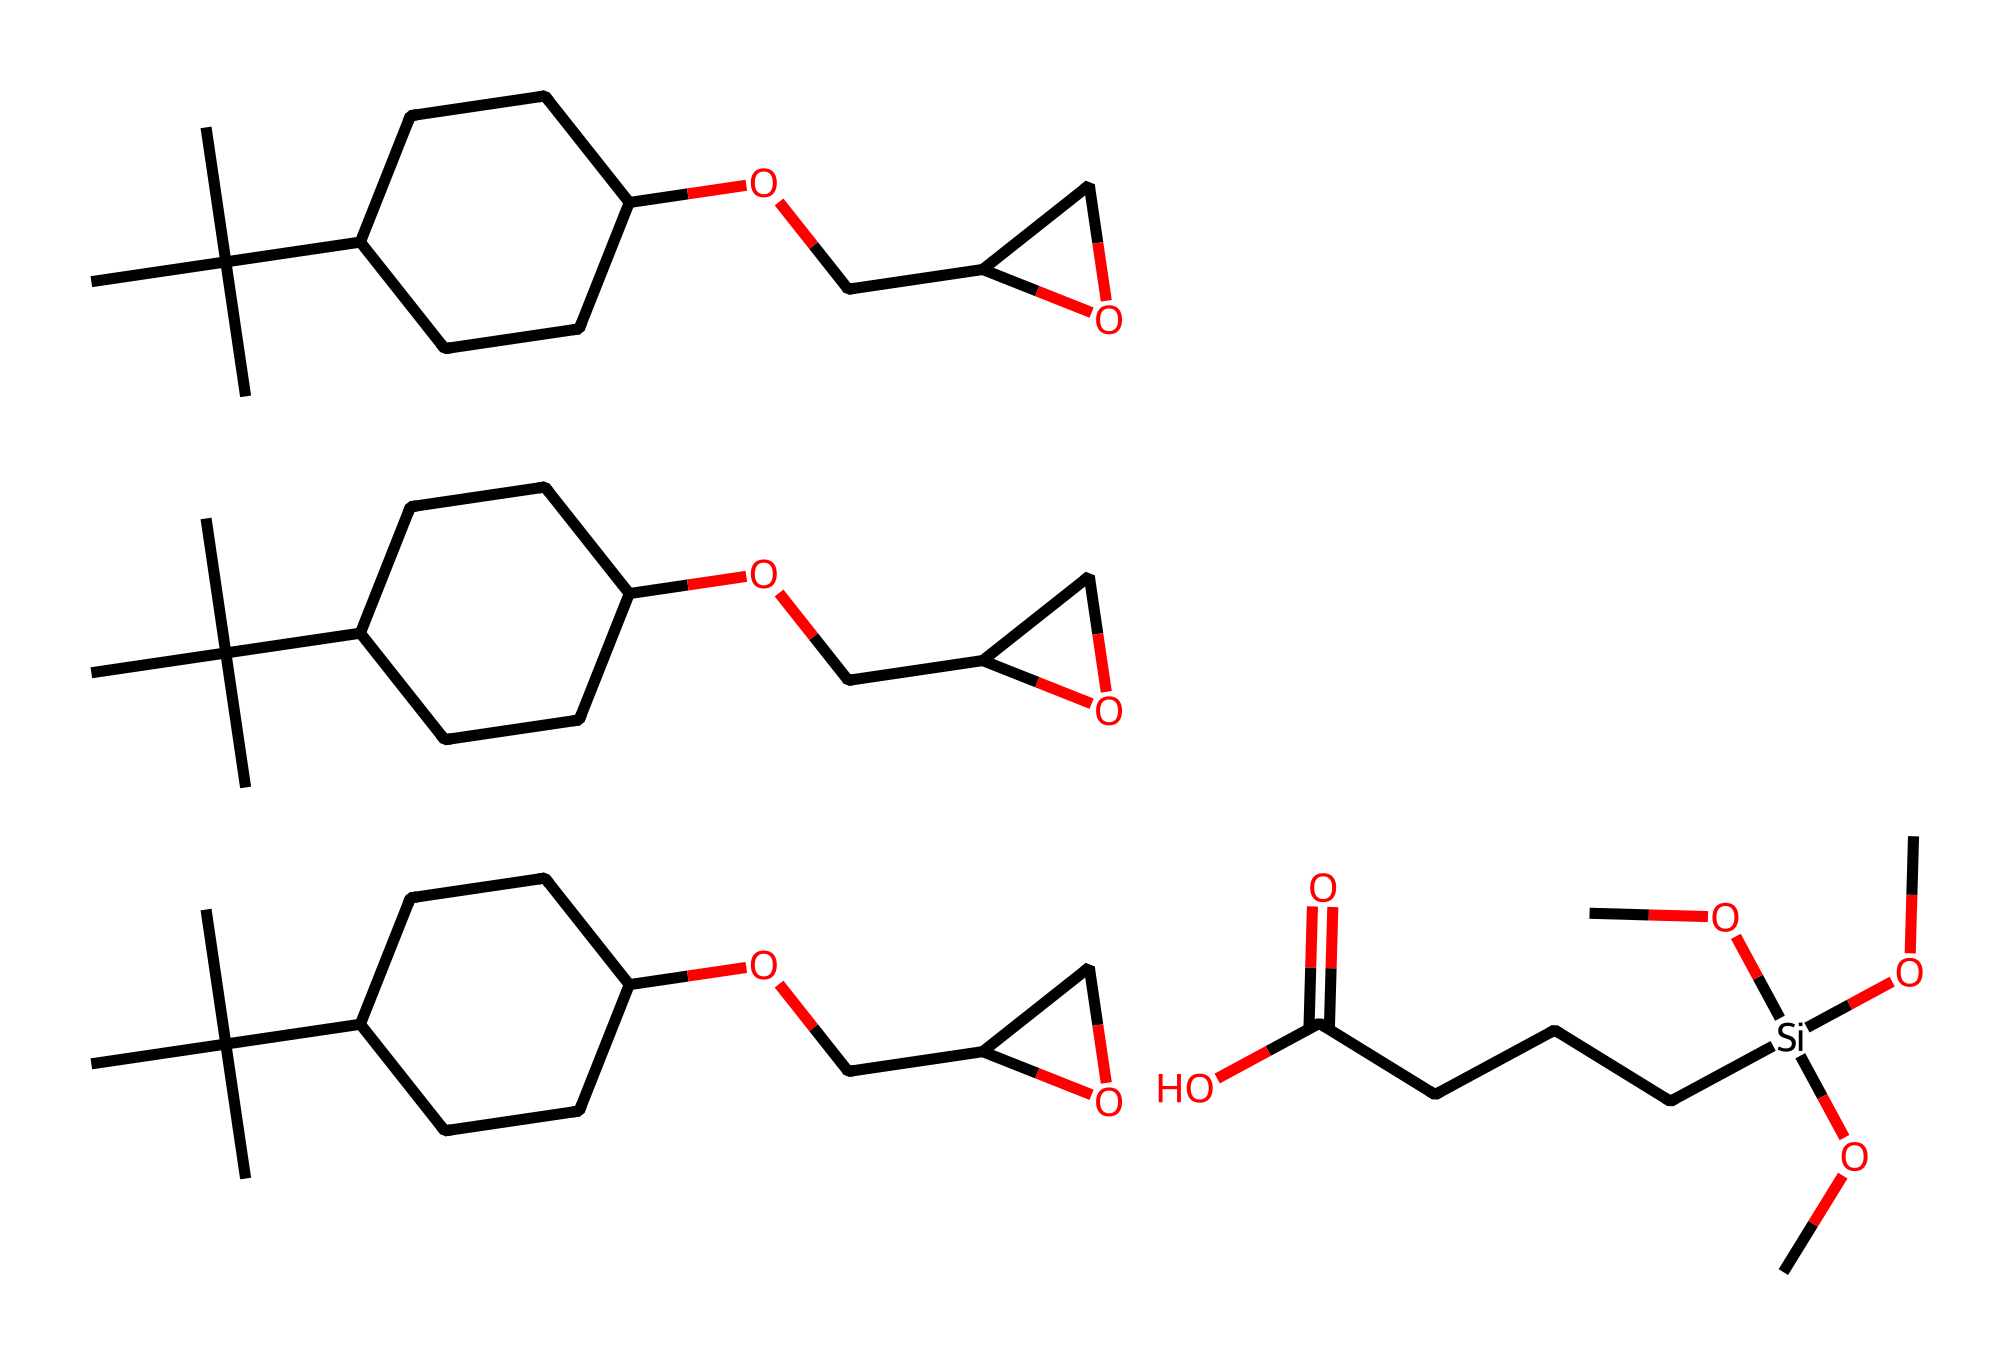What is the main functional group present in this molecule? The main functional group in this molecule is the silane group, which is identifiable by the presence of silicon atom bonded to three alkoxy groups and one organic moiety. This characteristic is key in silanes, distinguishing them from other organic compounds.
Answer: silane How many silicon atoms are present in the structure? Upon examining the chemical structure, there is one silicon atom that is bonded to four groups, which include three alkoxy groups and a carbon chain. This is typical for a silane compound where silicon holds a tetravalent position.
Answer: one What type of chemical interaction is facilitated by silanes in adhesives? Silanes can form strong covalent bonds with hydroxyl groups present on substrates; this property allows them to act as coupling agents, improving adhesion properties. This interaction is essential in creating durable and effective adhesives.
Answer: covalent bonds What does the presence of multiple alkoxy groups suggest about the solubility properties of this compound? The multiple alkoxy groups in the structure indicate that the molecule is likely to be soluble in polar solvents, enhancing its ability to interact with other polar substrates during adhesive applications.
Answer: polar solvents What structural feature allows silane-modified epoxy resins to be eco-friendly? The presence of bio-based or plant-derived groups in the structure indicates that this compound is designed to be environmentally friendly, aligning with sustainable chemistry practices. This aspect is critical in developing eco-friendly adhesives.
Answer: bio-based groups 